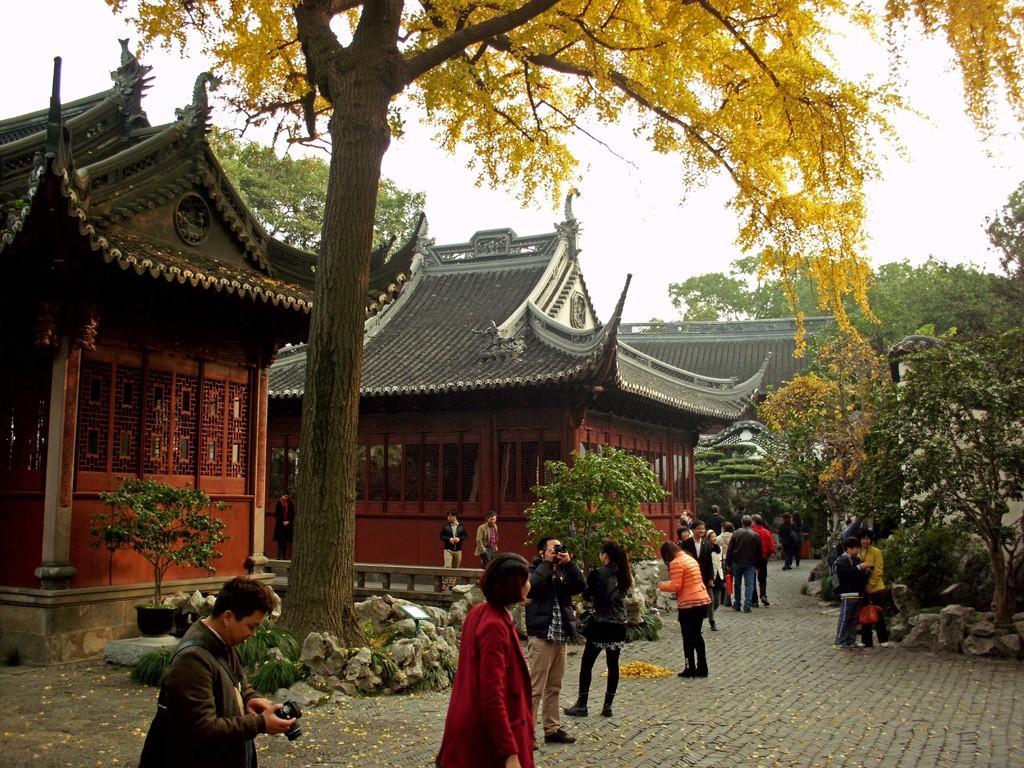Can you describe this image briefly? In the left side a man is standing by holding a camera, these are the houses which are in red color and in the middle it is a big tree, few other people are standing at here. 